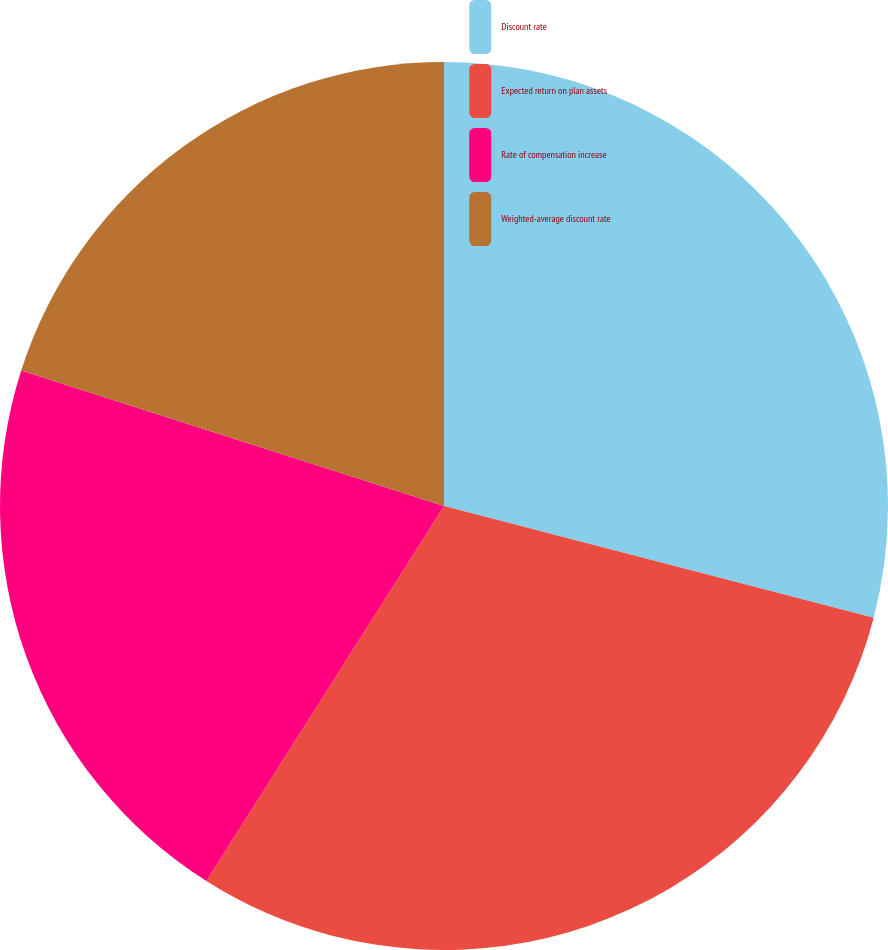Convert chart. <chart><loc_0><loc_0><loc_500><loc_500><pie_chart><fcel>Discount rate<fcel>Expected return on plan assets<fcel>Rate of compensation increase<fcel>Weighted-average discount rate<nl><fcel>29.05%<fcel>29.94%<fcel>20.95%<fcel>20.06%<nl></chart> 